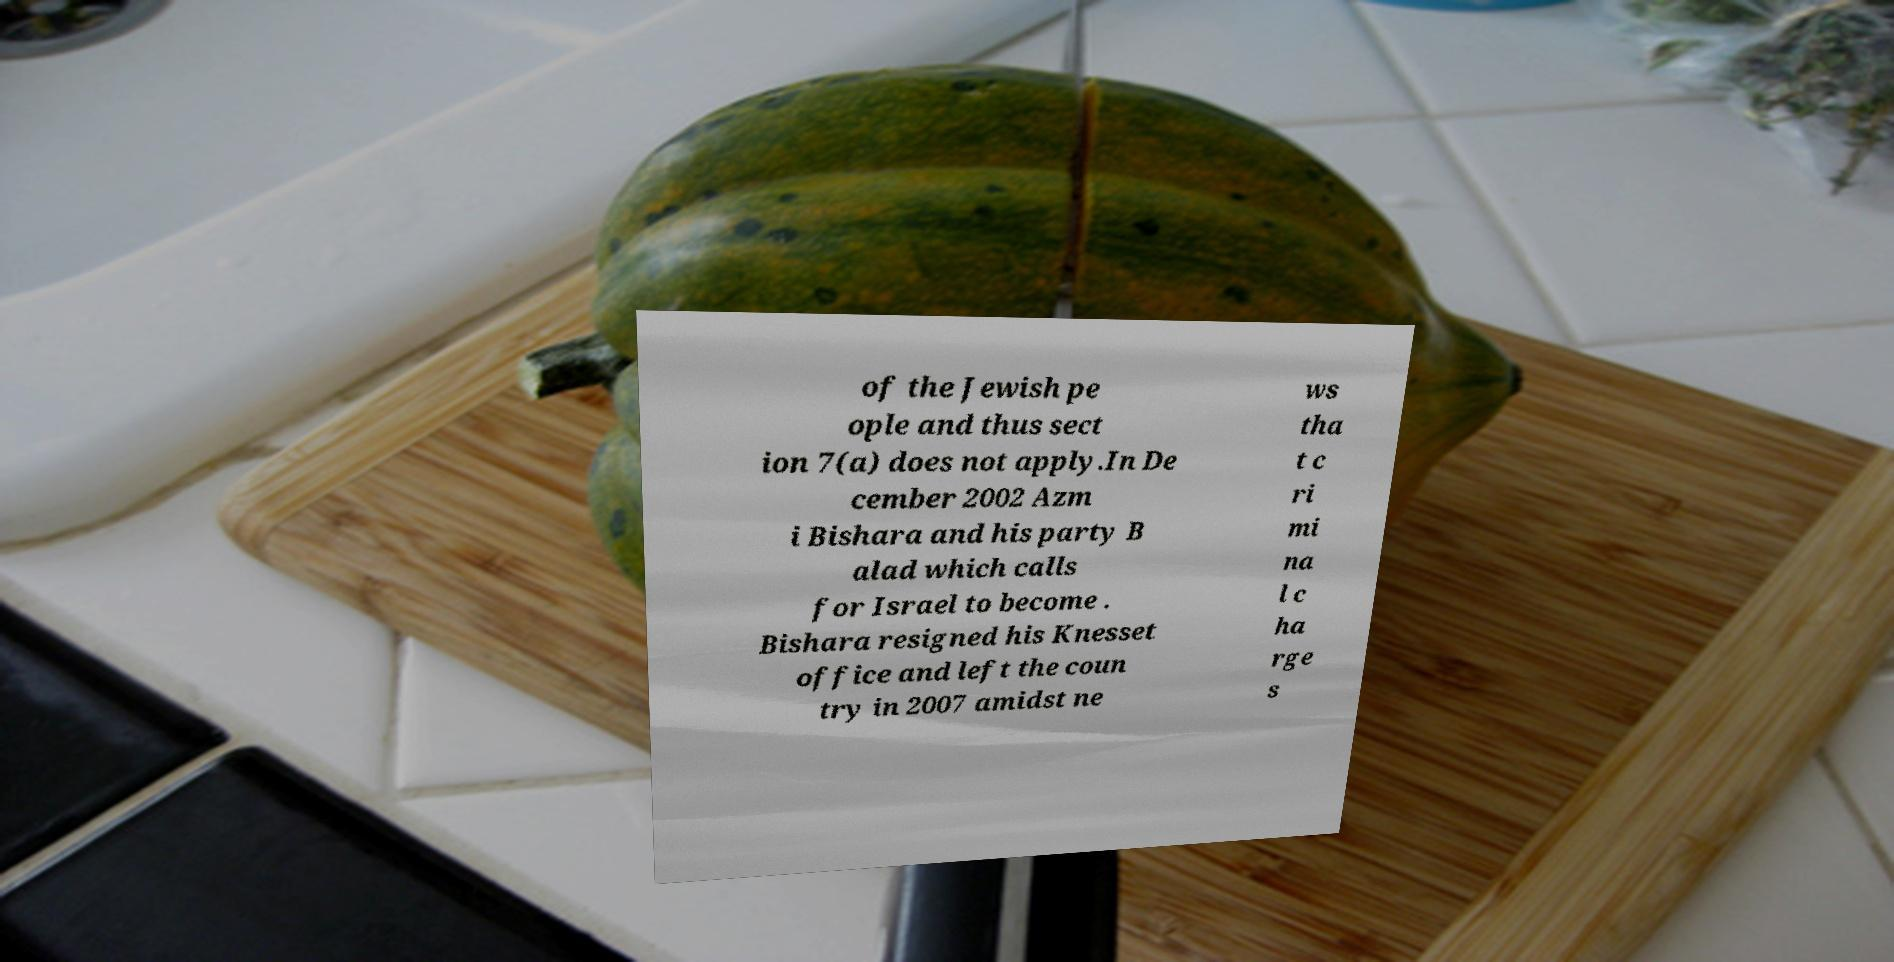For documentation purposes, I need the text within this image transcribed. Could you provide that? of the Jewish pe ople and thus sect ion 7(a) does not apply.In De cember 2002 Azm i Bishara and his party B alad which calls for Israel to become . Bishara resigned his Knesset office and left the coun try in 2007 amidst ne ws tha t c ri mi na l c ha rge s 